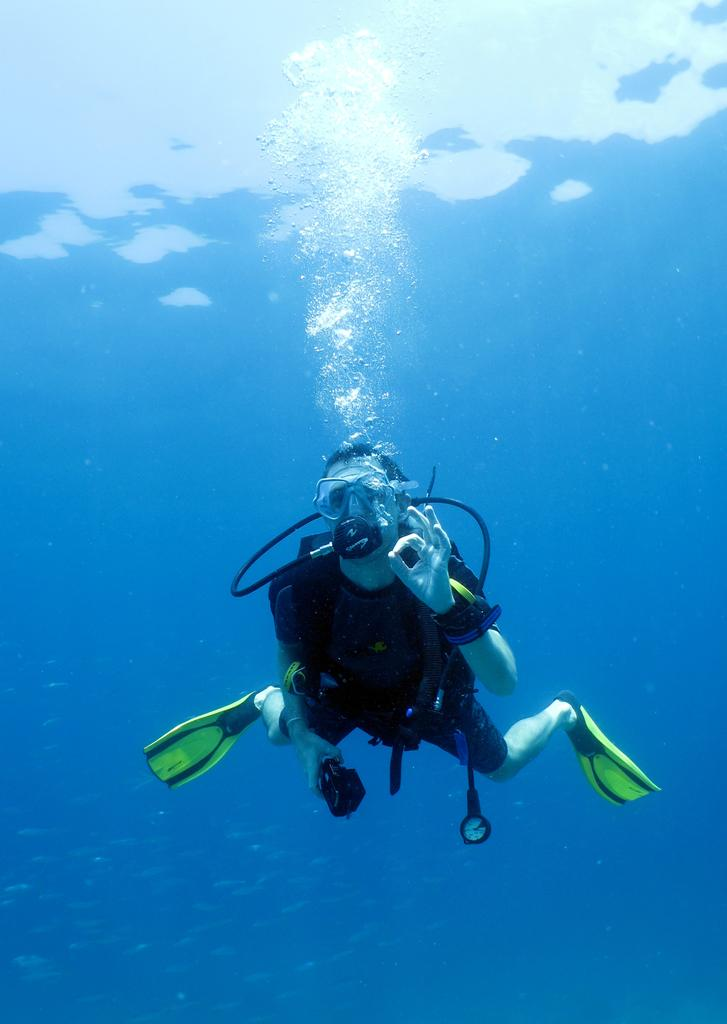What is the person in the image doing? The person is scuba diving. Where is the person located? The location is the ocean. What type of gate can be seen in the image? There is no gate present in the image; it features a person scuba diving in the ocean. 